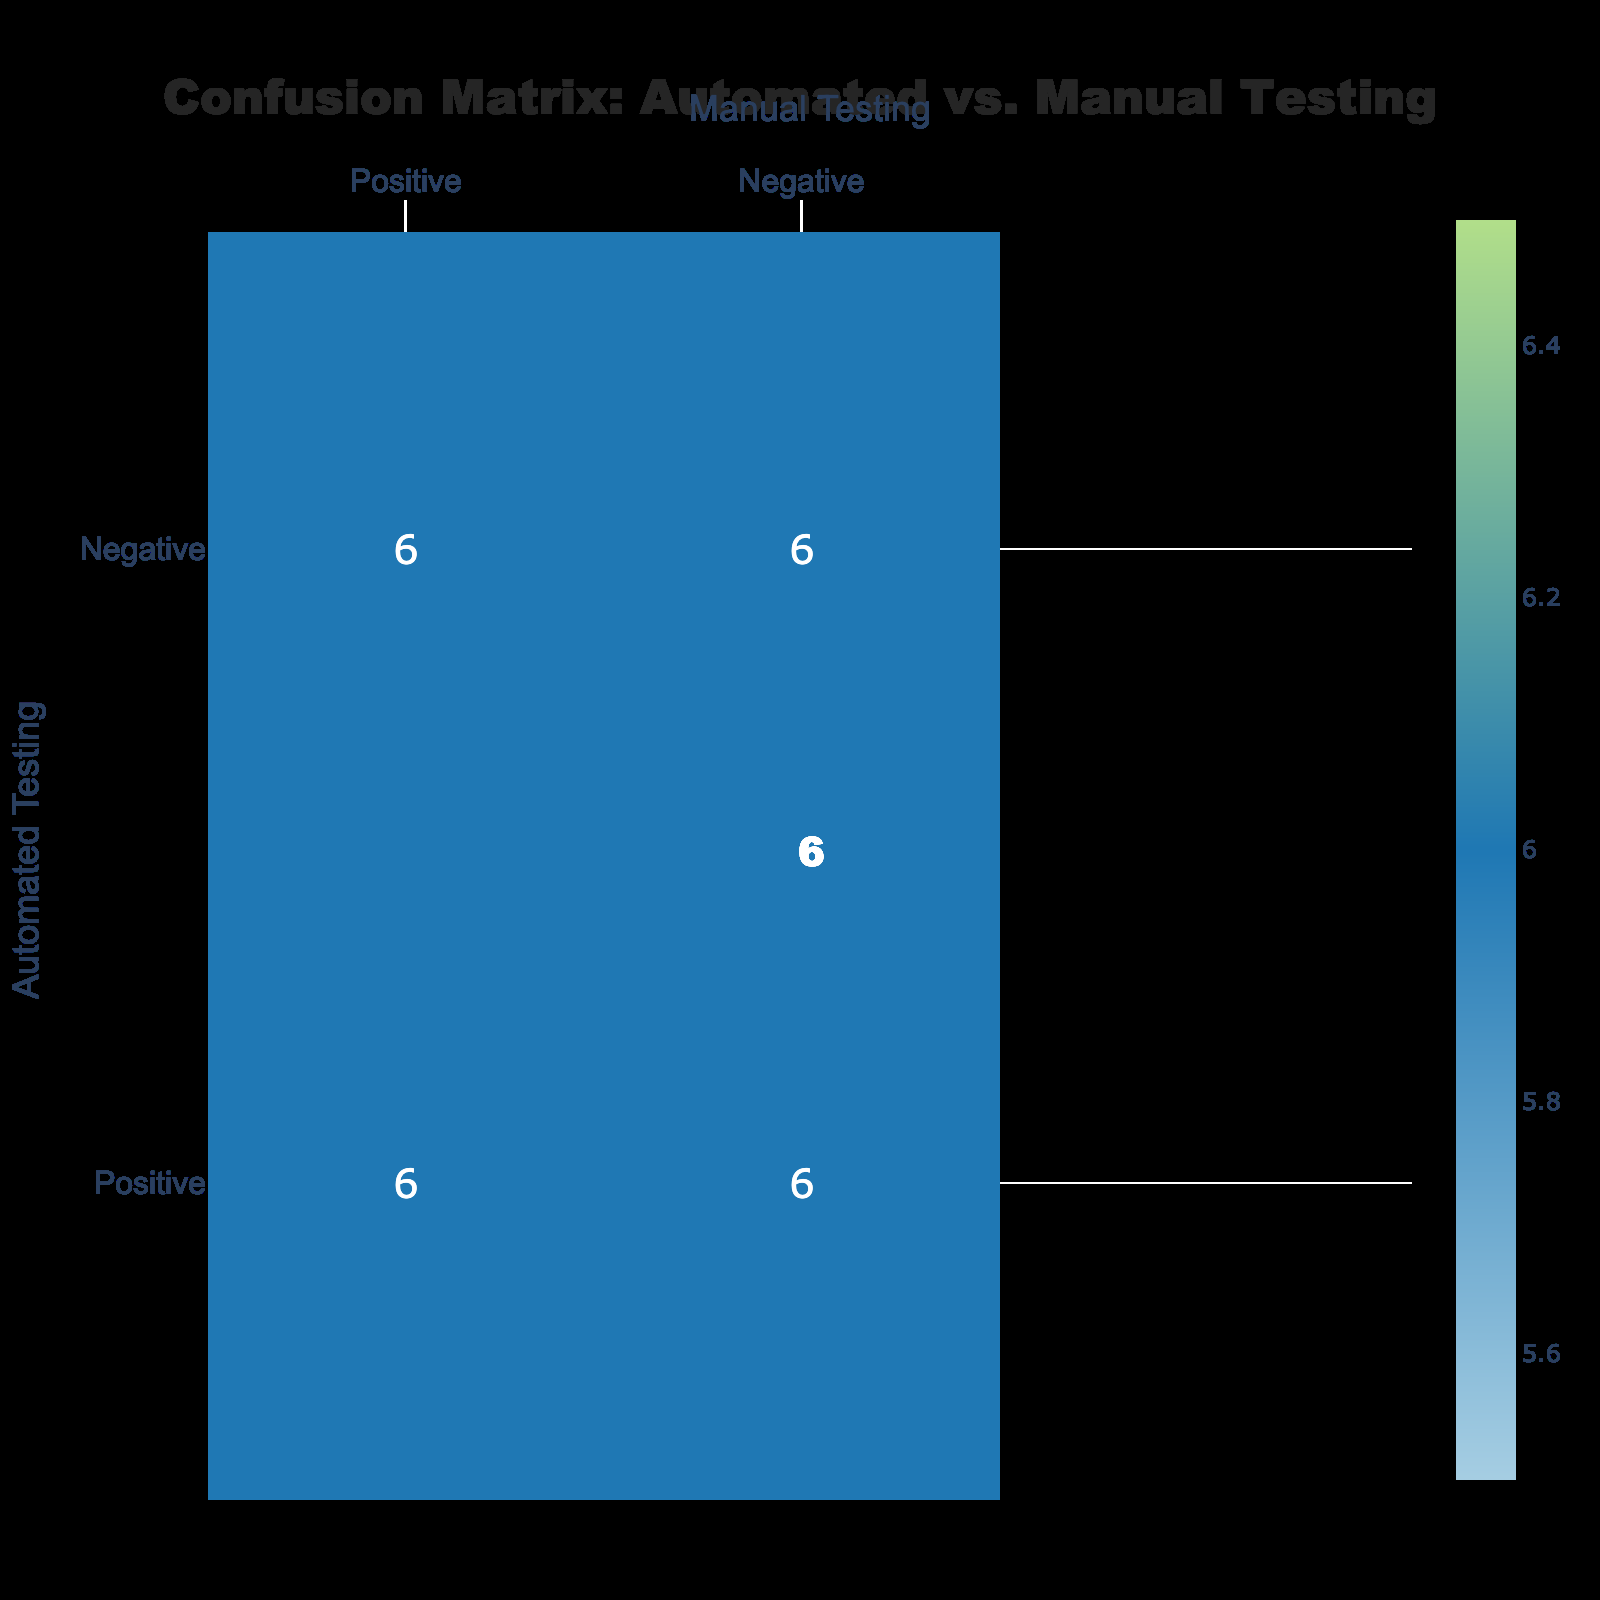What is the True Positive count for the User Registration feature? From the table, the "True Positive" count for the "User Registration" feature is explicitly stated in the row corresponding to that feature, which shows 1.
Answer: 1 What is the total number of False Positives across all features? To find the total number of False Positives, I sum the values from the "False Positive" column: 0 + 1 + 0 + 1 + 0 + 1 = 3.
Answer: 3 Did the Automated Testing pass for the Checkout Process feature? Looking at the "Checkout Process" row under "Automated Testing," it shows "Passed," confirming that Automated Testing passed for this feature.
Answer: Yes What is the difference between True Negatives and False Negatives across all features? First, I sum the True Negatives: 1 + 0 + 1 + 0 + 1 + 0 = 3. Then, I sum the False Negatives: 0 + 1 + 0 + 1 + 0 + 1 = 3. The difference is 3 - 3 = 0.
Answer: 0 How many features had a False Positive during Automated Testing? By checking each "False Positive" count in the table, the "Login Feature," "Checkout Process," "User Registration," "Profile Update," "Search Functionality," and "Payment Processing" count one each, totaling 5 features with False Positives.
Answer: 5 Which feature had both a True Positive count of 1 and a False Negative count of 0? The features satisfying this condition are "Login Feature," "Checkout Process," "User Registration," and "Search Functionality," as they all have a True Positive of 1 and a False Negative of 0.
Answer: Login Feature, Checkout Process, User Registration, Search Functionality How many Total Passes were recorded across both testing types? To determine Total Passes, I look at the "Passed" columns for both Automated and Manual Testing: 6 pass results from Automated (counting all rows with 'Passed') and manually from the rows—4 were marked as Passed, so total is 6 + 4 = 10.
Answer: 10 Was there any feature that both automated and manual testing failed? Observing the table, the only feature where both types of testing failed is in "User Registration," as it shows "Failed" for both testing methods.
Answer: Yes What is the percentage of True Positives in relation to all outcomes for the Profile Update feature? For "Profile Update," the True Positive is 1, and the total outcomes (True Positive + False Positive + True Negative + False Negative) are 1 + 1 + 0 + 0 = 2. The percentage is (1/2)*100 = 50%.
Answer: 50% 